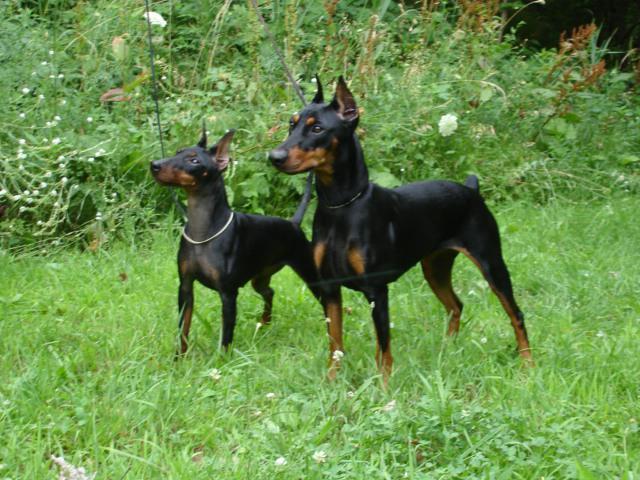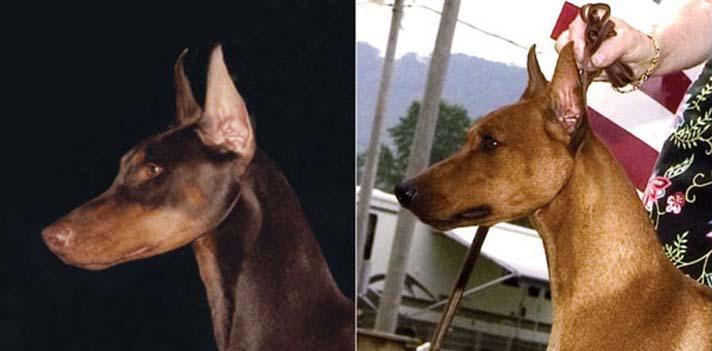The first image is the image on the left, the second image is the image on the right. Analyze the images presented: Is the assertion "The right image contains no more than two dogs." valid? Answer yes or no. Yes. The first image is the image on the left, the second image is the image on the right. Assess this claim about the two images: "In the left image, two dogs are standing side-by-side, with their bodies and heads turned in the same direction.". Correct or not? Answer yes or no. Yes. 